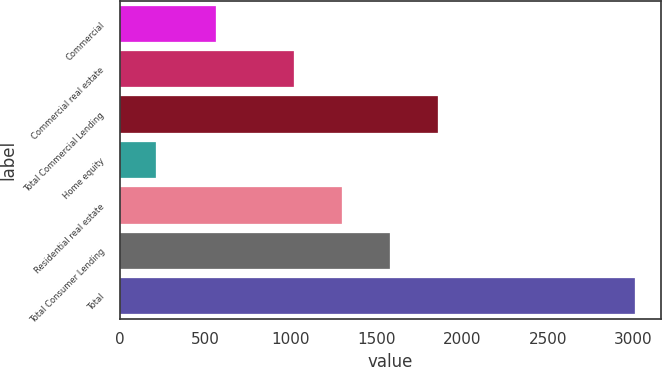Convert chart. <chart><loc_0><loc_0><loc_500><loc_500><bar_chart><fcel>Commercial<fcel>Commercial real estate<fcel>Total Commercial Lending<fcel>Home equity<fcel>Residential real estate<fcel>Total Consumer Lending<fcel>Total<nl><fcel>564<fcel>1018<fcel>1856.8<fcel>215<fcel>1297.6<fcel>1577.2<fcel>3011<nl></chart> 